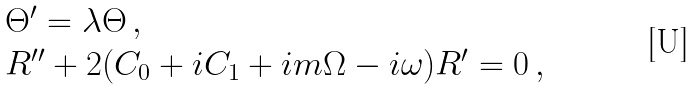Convert formula to latex. <formula><loc_0><loc_0><loc_500><loc_500>\begin{array} { l l } & \Theta ^ { \prime } = \lambda \Theta \, , \\ & R ^ { \prime \prime } + 2 ( C _ { 0 } + i C _ { 1 } + i m \Omega - i \omega ) R ^ { \prime } = 0 \, , \end{array}</formula> 